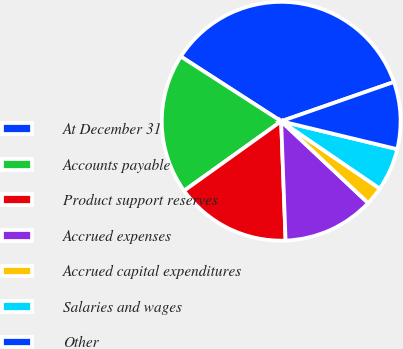Convert chart. <chart><loc_0><loc_0><loc_500><loc_500><pie_chart><fcel>At December 31<fcel>Accounts payable<fcel>Product support reserves<fcel>Accrued expenses<fcel>Accrued capital expenditures<fcel>Salaries and wages<fcel>Other<nl><fcel>35.55%<fcel>19.01%<fcel>15.7%<fcel>12.4%<fcel>2.47%<fcel>5.78%<fcel>9.09%<nl></chart> 